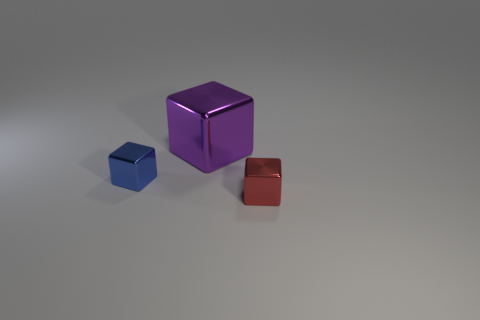Add 2 yellow blocks. How many objects exist? 5 Subtract all small blocks. How many blocks are left? 1 Subtract all blue balls. How many red blocks are left? 1 Subtract all big purple cubes. Subtract all purple blocks. How many objects are left? 1 Add 3 small red shiny things. How many small red shiny things are left? 4 Add 2 tiny cyan cubes. How many tiny cyan cubes exist? 2 Subtract all purple cubes. How many cubes are left? 2 Subtract 0 yellow spheres. How many objects are left? 3 Subtract 1 cubes. How many cubes are left? 2 Subtract all gray blocks. Subtract all brown cylinders. How many blocks are left? 3 